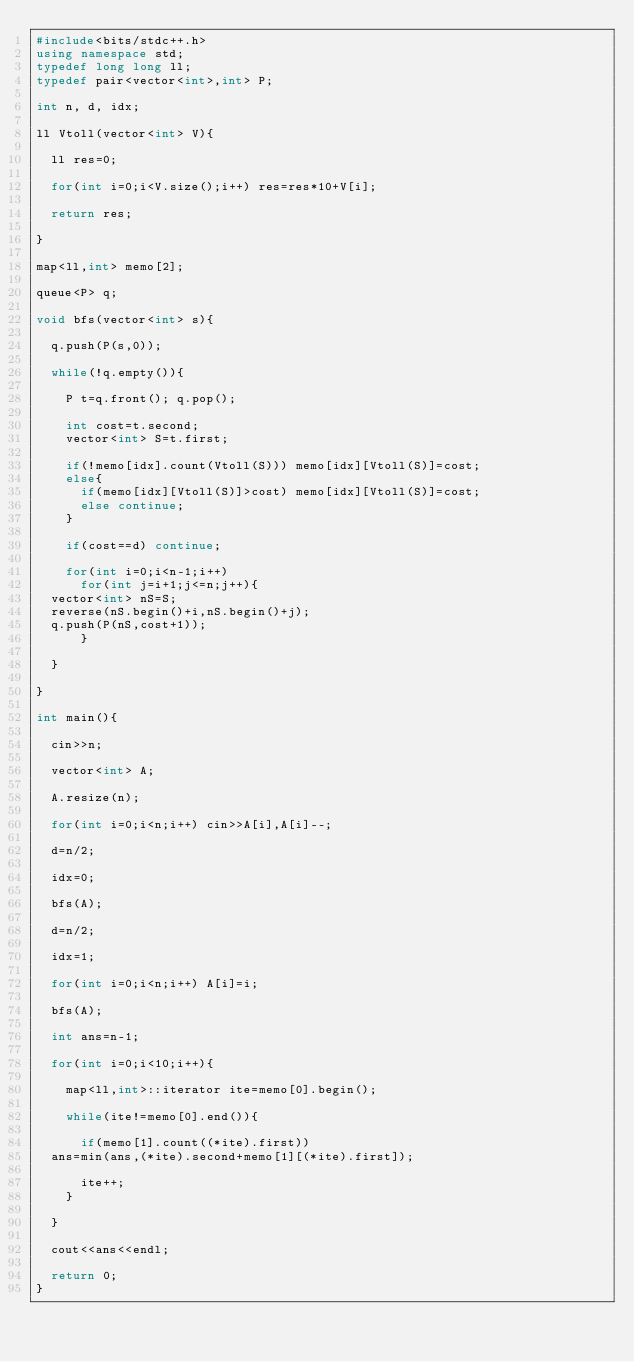<code> <loc_0><loc_0><loc_500><loc_500><_C++_>#include<bits/stdc++.h>
using namespace std;
typedef long long ll;
typedef pair<vector<int>,int> P;

int n, d, idx;

ll Vtoll(vector<int> V){
  
  ll res=0;
  
  for(int i=0;i<V.size();i++) res=res*10+V[i];
  
  return res;
  
}

map<ll,int> memo[2];

queue<P> q;

void bfs(vector<int> s){
  
  q.push(P(s,0));
  
  while(!q.empty()){

    P t=q.front(); q.pop();

    int cost=t.second;
    vector<int> S=t.first;
    
    if(!memo[idx].count(Vtoll(S))) memo[idx][Vtoll(S)]=cost;
    else{
      if(memo[idx][Vtoll(S)]>cost) memo[idx][Vtoll(S)]=cost;
      else continue;
    }
    
    if(cost==d) continue;
    
    for(int i=0;i<n-1;i++)
      for(int j=i+1;j<=n;j++){
	vector<int> nS=S;
	reverse(nS.begin()+i,nS.begin()+j);
	q.push(P(nS,cost+1));
      }
    
  }
  
}

int main(){
  
  cin>>n;
  
  vector<int> A;
  
  A.resize(n);
  
  for(int i=0;i<n;i++) cin>>A[i],A[i]--;

  d=n/2;
  
  idx=0;
  
  bfs(A);

  d=n/2;
    
  idx=1;
  
  for(int i=0;i<n;i++) A[i]=i;
  
  bfs(A);

  int ans=n-1;

  for(int i=0;i<10;i++){
    
    map<ll,int>::iterator ite=memo[0].begin();

    while(ite!=memo[0].end()){
      
      if(memo[1].count((*ite).first))
	ans=min(ans,(*ite).second+memo[1][(*ite).first]);
      
      ite++;
    }
    
  }

  cout<<ans<<endl;
  
  return 0;
}</code> 